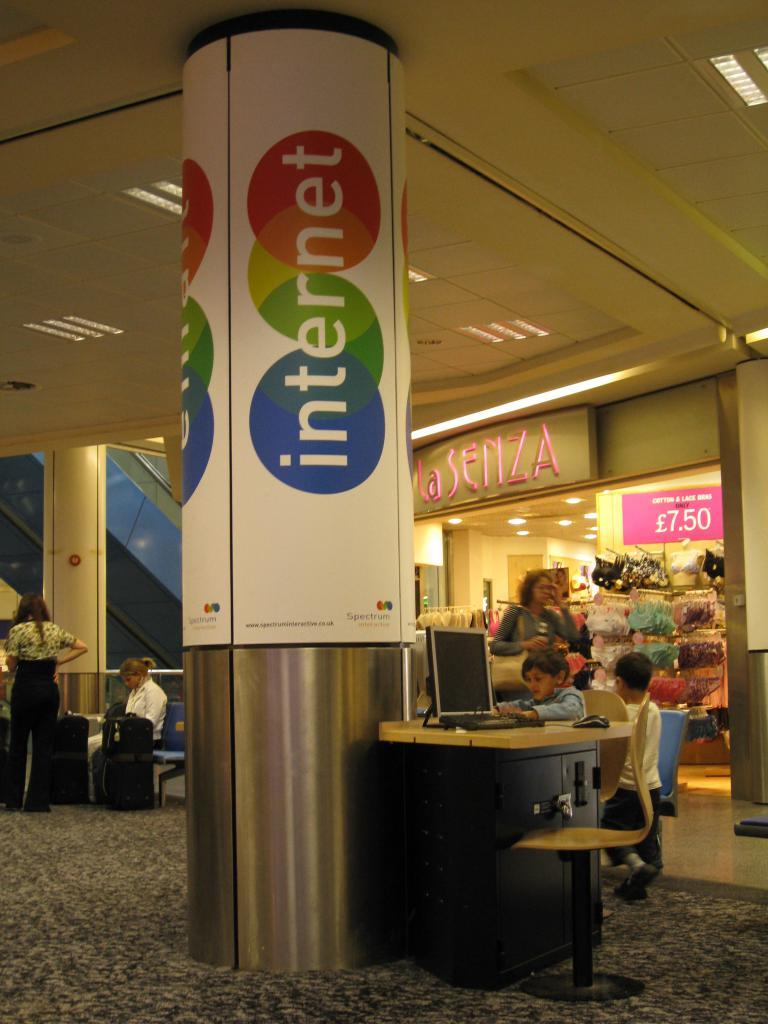What is located in the center of the room? There is a pillar in the center of the room. What piece of furniture is present in the room? There is a table in the room. What is on the table? A system is present on the table. What can be seen near the pillar? There are people around the pillar. Where is the faucet located in the room? There is no faucet present in the image. What type of sport is being played in the room? There is no indication of any sport being played in the room; people are simply standing near the pillar. 